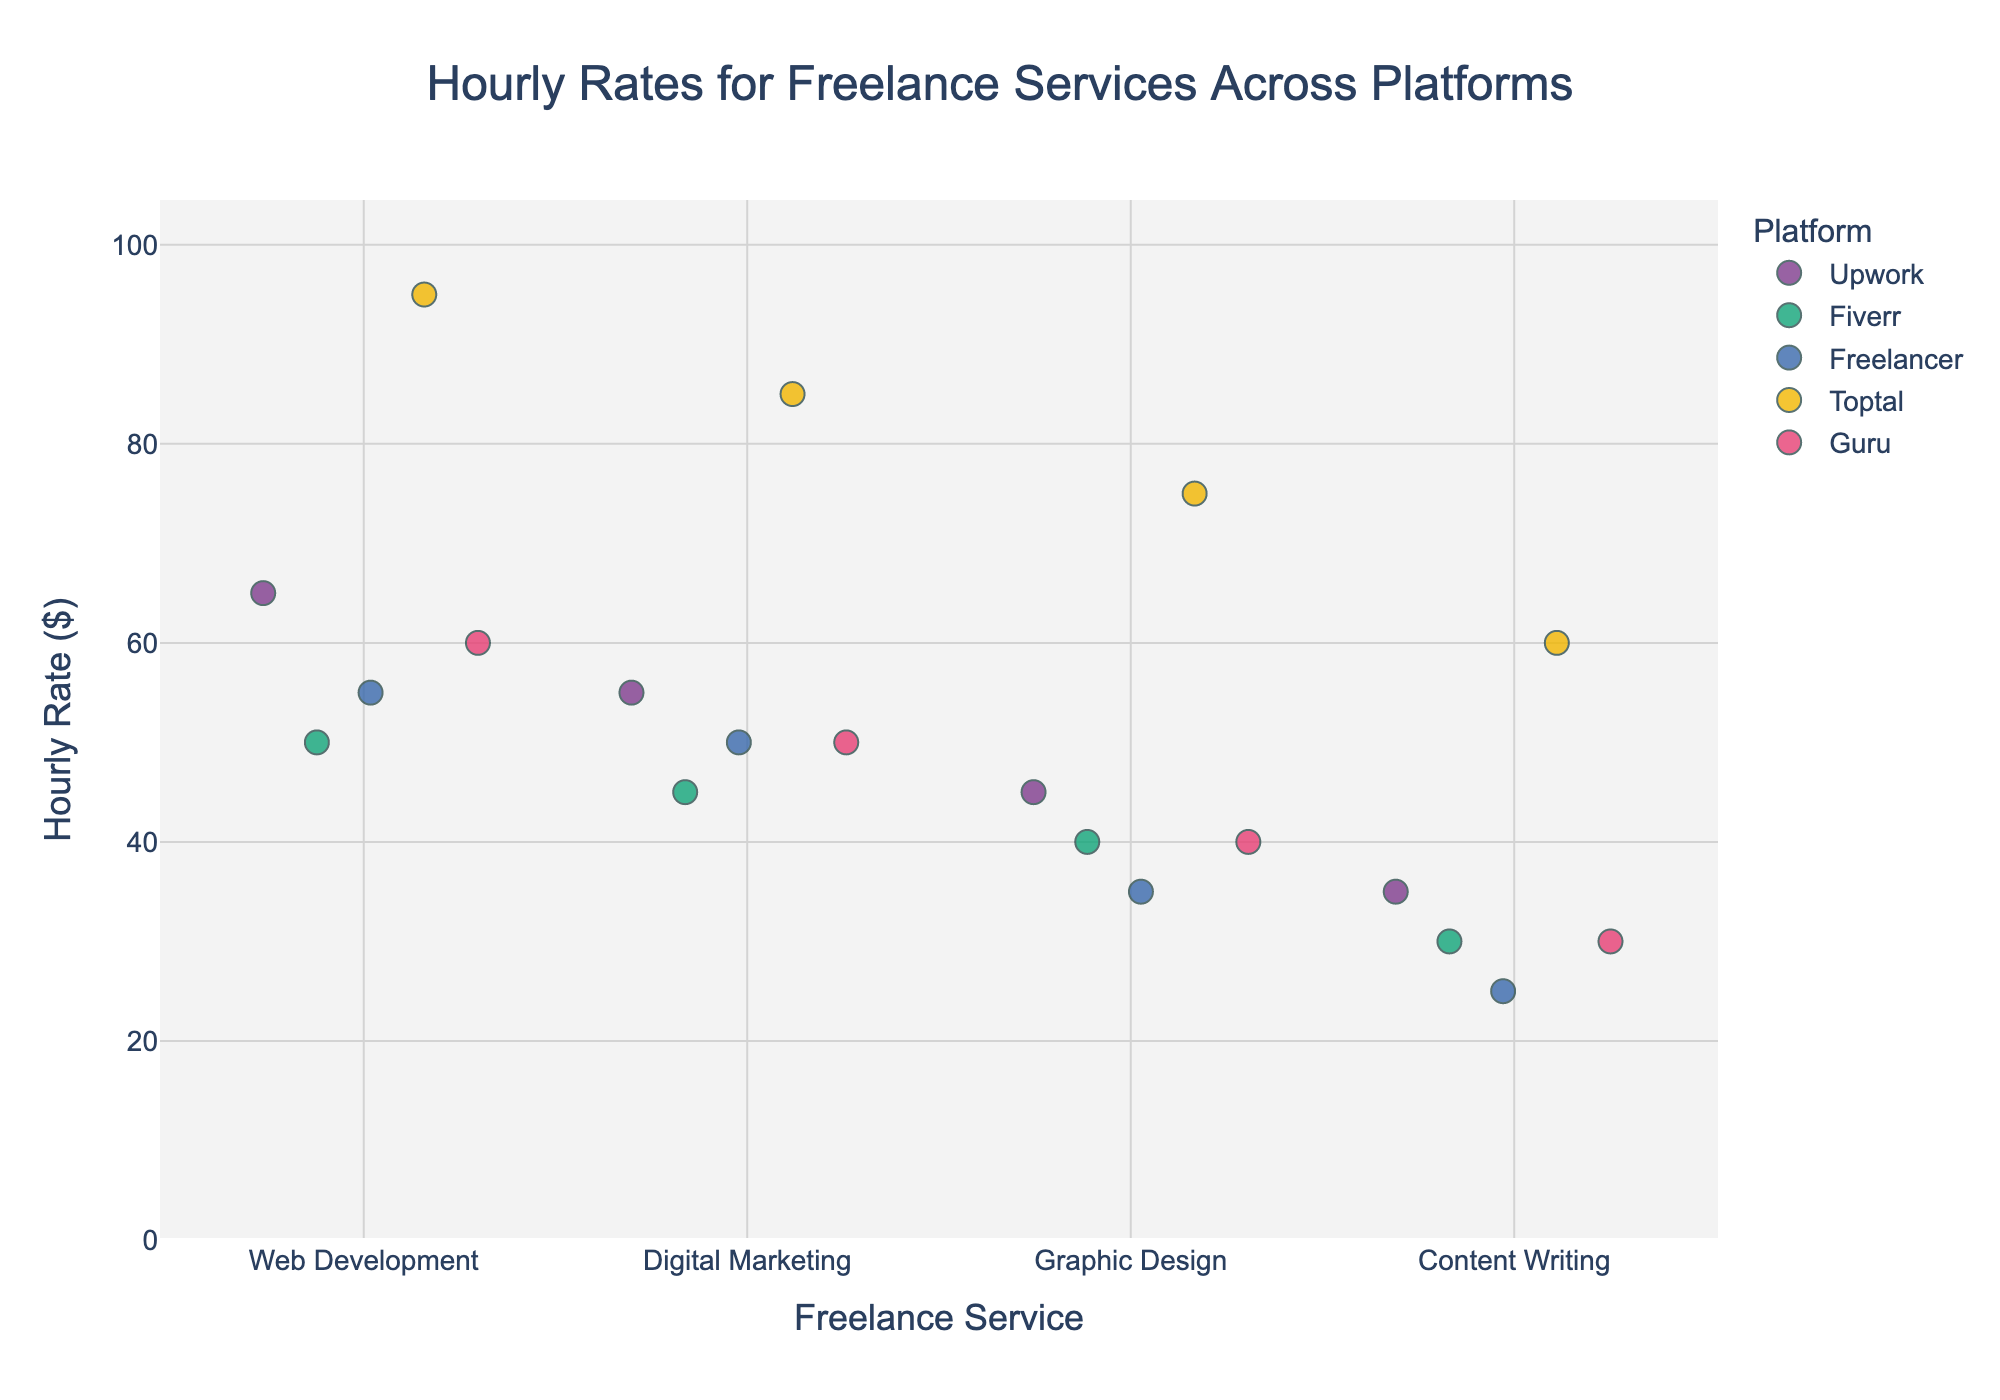What is the title of the plot? The title is located at the top of the plot, centered. It typically describes the main purpose of the plot.
Answer: Hourly Rates for Freelance Services Across Platforms Which platform has the highest hourly rate for Web Development? To find this, look for the highest point in the Web Development category, and note the corresponding platform.
Answer: Toptal How many graphic design hourly rates are there for each platform? Count the number of points for each platform in the Graphic Design category. Upwork, Fiverr, Freelancer, and Guru each have 1 point, while Toptal also has 1 point.
Answer: 5 What's the average hourly rate for Digital Marketing across all platforms? Add together all the hourly rates for Digital Marketing and divide by the number of data points in that category. Specifically, (55 + 45 + 50 + 85 + 50) / 5 = 57.
Answer: 57 Which service category has the highest variability in hourly rates? Variability can be visually estimated by observing the spread of the data points within each service category. Web Development shows wide spread across platforms ranging from 50 to 95, thus demonstrating high variability.
Answer: Web Development What is the hourly rate range for Content Writing on Freelancer? Identify the minimum and maximum points within the Content Writing category for Freelancer. Freelancer's rates show a single point at 25.
Answer: 25 Compare the highest hourly rate between Graphic Design and Content Writing. Which one is higher and by how much? Identify the highest points for Graphic Design (75, Toptal) and Content Writing (60, Toptal), then subtract the latter from the former. 75 - 60 = 15.
Answer: Graphic Design is higher by 15 What is the median hourly rate for the Web Development service category? To determine the median, list all hourly rates in the Web Development category in ascending order (50, 55, 55, 60, 65, 95) and find the middle value. The median is the average of the middle two values, (55 + 60) / 2 = 57.5.
Answer: 57.5 Which platform offers the lowest hourly rate for any service, and what is that rate? Identify the lowest point across all service categories and note the corresponding platform and rate. The lowest rate is 25, offered by Freelancer for Content Writing.
Answer: Freelancer at 25 